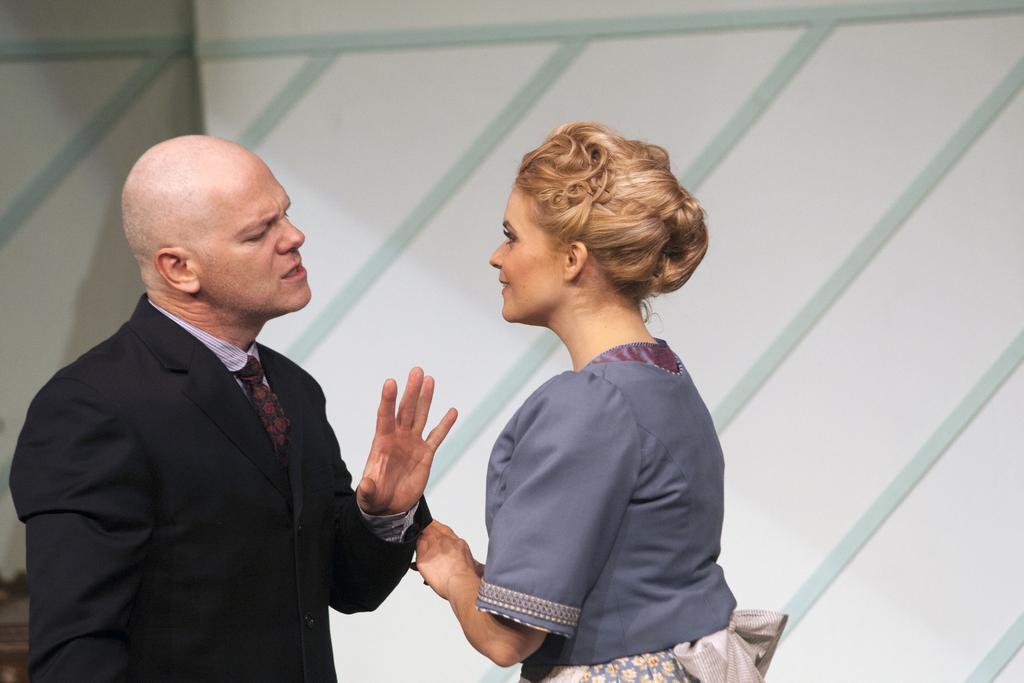Describe this image in one or two sentences. In this image we can see a man and a woman. In the background there is a wall. 